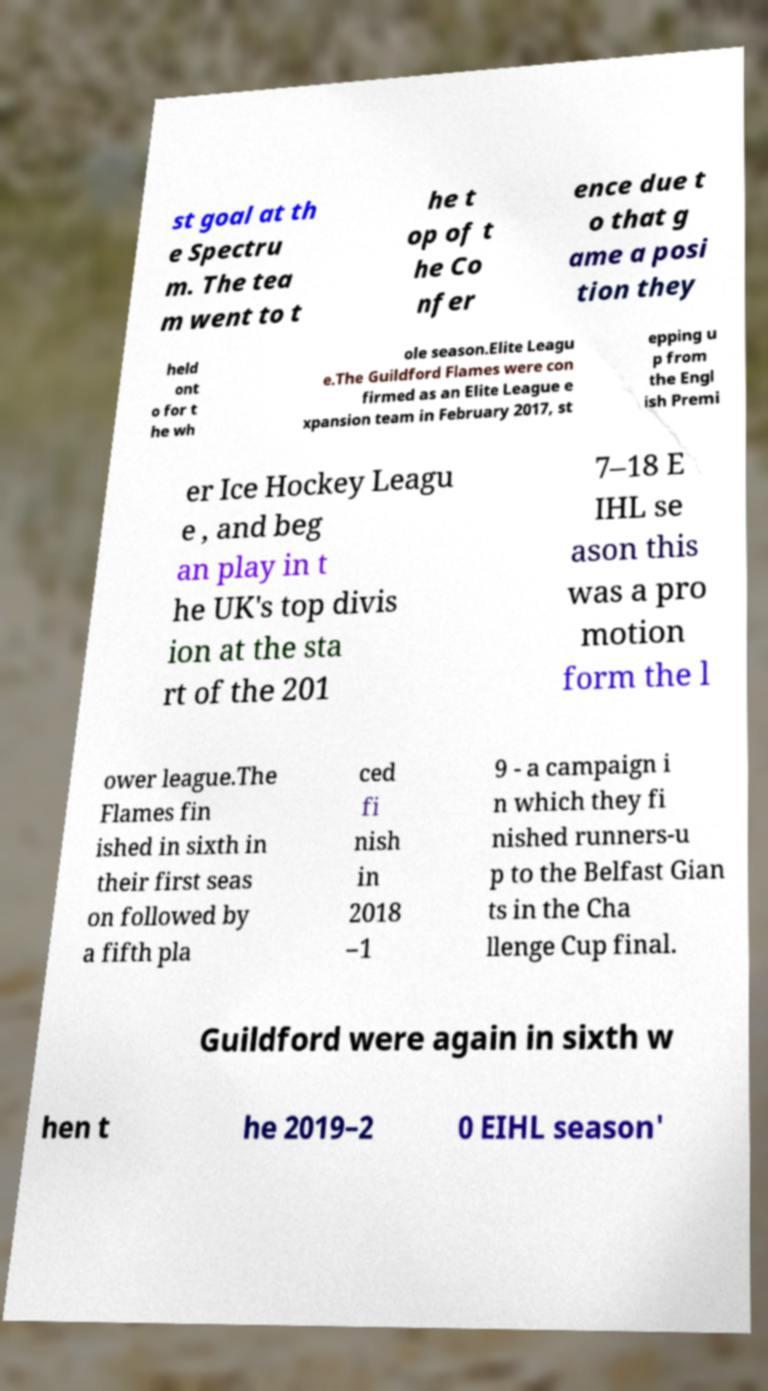Please identify and transcribe the text found in this image. st goal at th e Spectru m. The tea m went to t he t op of t he Co nfer ence due t o that g ame a posi tion they held ont o for t he wh ole season.Elite Leagu e.The Guildford Flames were con firmed as an Elite League e xpansion team in February 2017, st epping u p from the Engl ish Premi er Ice Hockey Leagu e , and beg an play in t he UK's top divis ion at the sta rt of the 201 7–18 E IHL se ason this was a pro motion form the l ower league.The Flames fin ished in sixth in their first seas on followed by a fifth pla ced fi nish in 2018 –1 9 - a campaign i n which they fi nished runners-u p to the Belfast Gian ts in the Cha llenge Cup final. Guildford were again in sixth w hen t he 2019–2 0 EIHL season' 